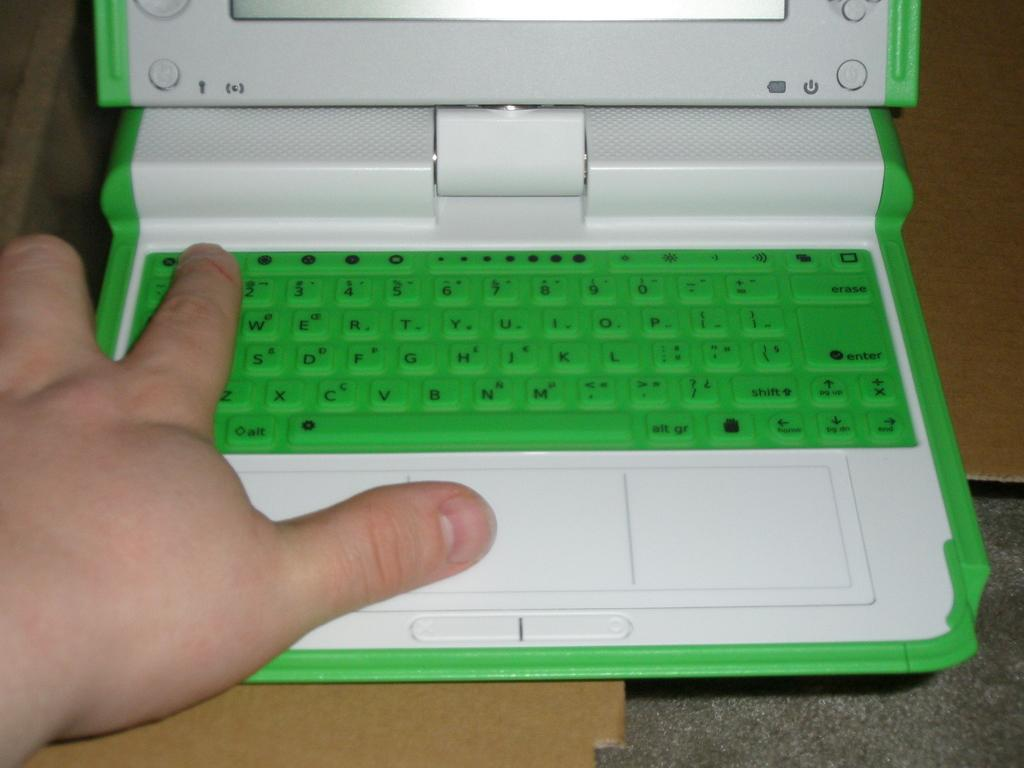<image>
Create a compact narrative representing the image presented. Someone has their hand on a green and white laptop's keyboard with their index finger on the number 1 key. 